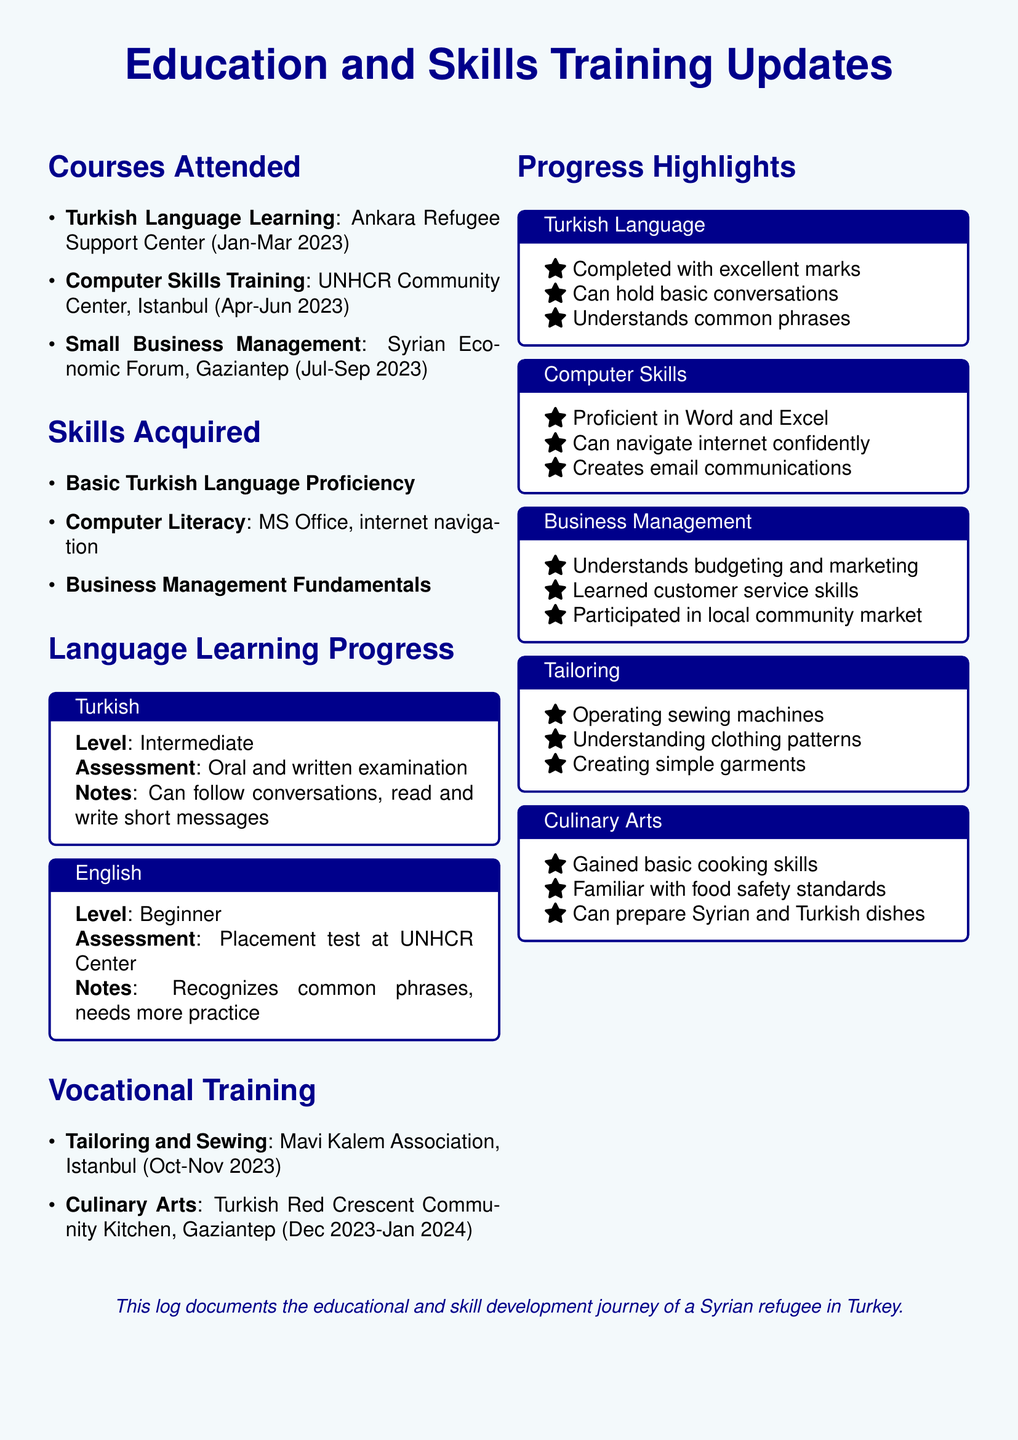What courses were attended? The courses attended include Turkish Language Learning, Computer Skills Training, and Small Business Management as listed in the document.
Answer: Turkish Language Learning, Computer Skills Training, Small Business Management What organization provided the Computer Skills Training? The document specifies that the Computer Skills Training was provided by the UNHCR Community Center.
Answer: UNHCR Community Center What is the proficiency level of Turkish? The document states the level of Turkish language proficiency as Intermediate.
Answer: Intermediate What skills were gained from the Tailoring and Sewing course? The skills acquired from the Tailoring and Sewing course include operating sewing machines, understanding clothing patterns, and creating simple garments.
Answer: Operating sewing machines, understanding clothing patterns, creating simple garments How long did the Turkish Language Learning course last? The duration of the Turkish Language Learning course is from January to March 2023, which is a three-month period.
Answer: Three months What is the assessment method for English learning? The document mentions that the assessment for English learning was conducted through a placement test at the UNHCR Center.
Answer: Placement test at UNHCR Center Which vocational training will begin in December 2023? The document indicates that the Culinary Arts training will begin in December 2023.
Answer: Culinary Arts What are the highlights of progress in Computer Skills? The document highlights that the individual is proficient in Word and Excel, can navigate the internet confidently, and creates email communications.
Answer: Proficient in Word and Excel, can navigate internet confidently, creates email communications 